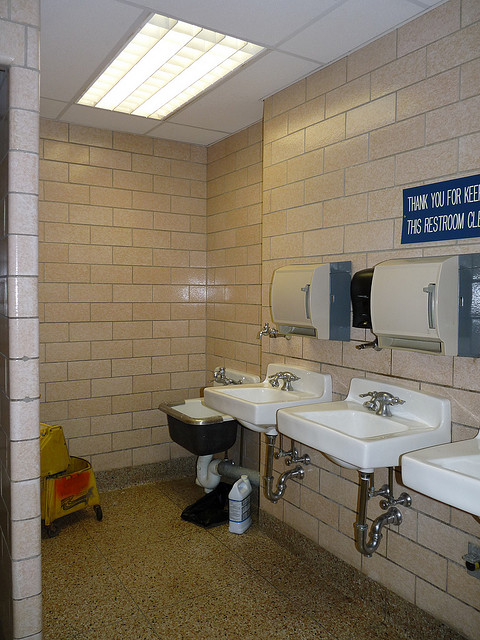Is the skylight so that users can tan themselves?
Answer the question using a single word or phrase. No Is there more than one sink? Yes Is this a public restroom? Yes 